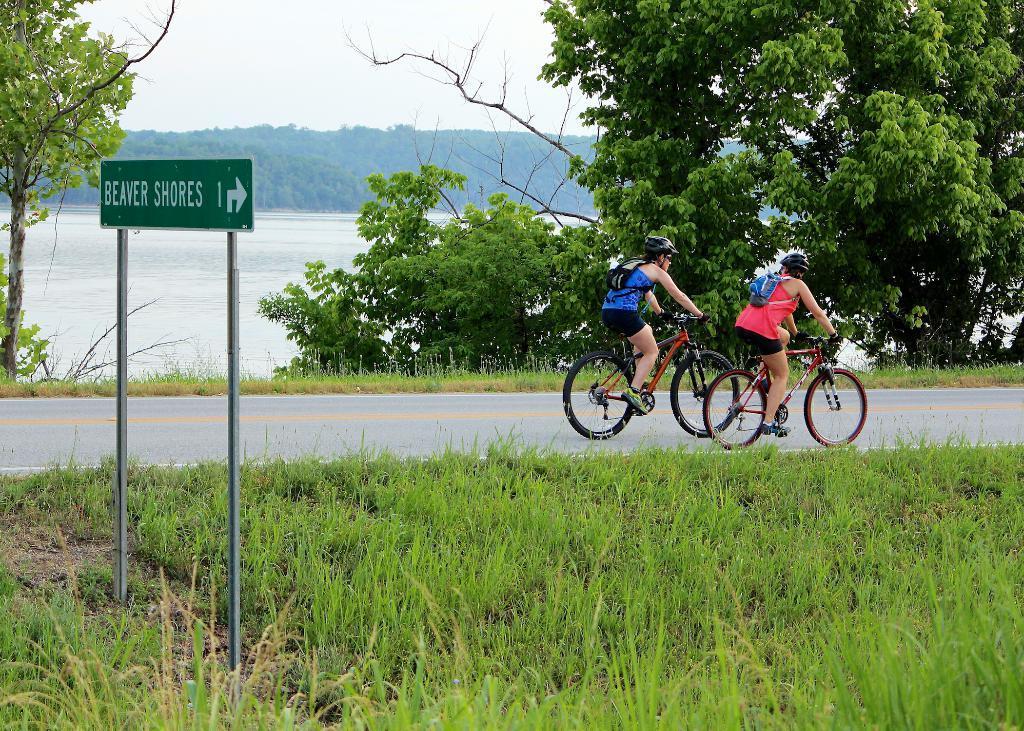Could you give a brief overview of what you see in this image? In this picture we can see two women wearing boots and riding on the bicycles on the path. There is a signboard on the poles. Some grass is visible on the ground. There are few trees from left to right. We can see water and some greenery in the background. 